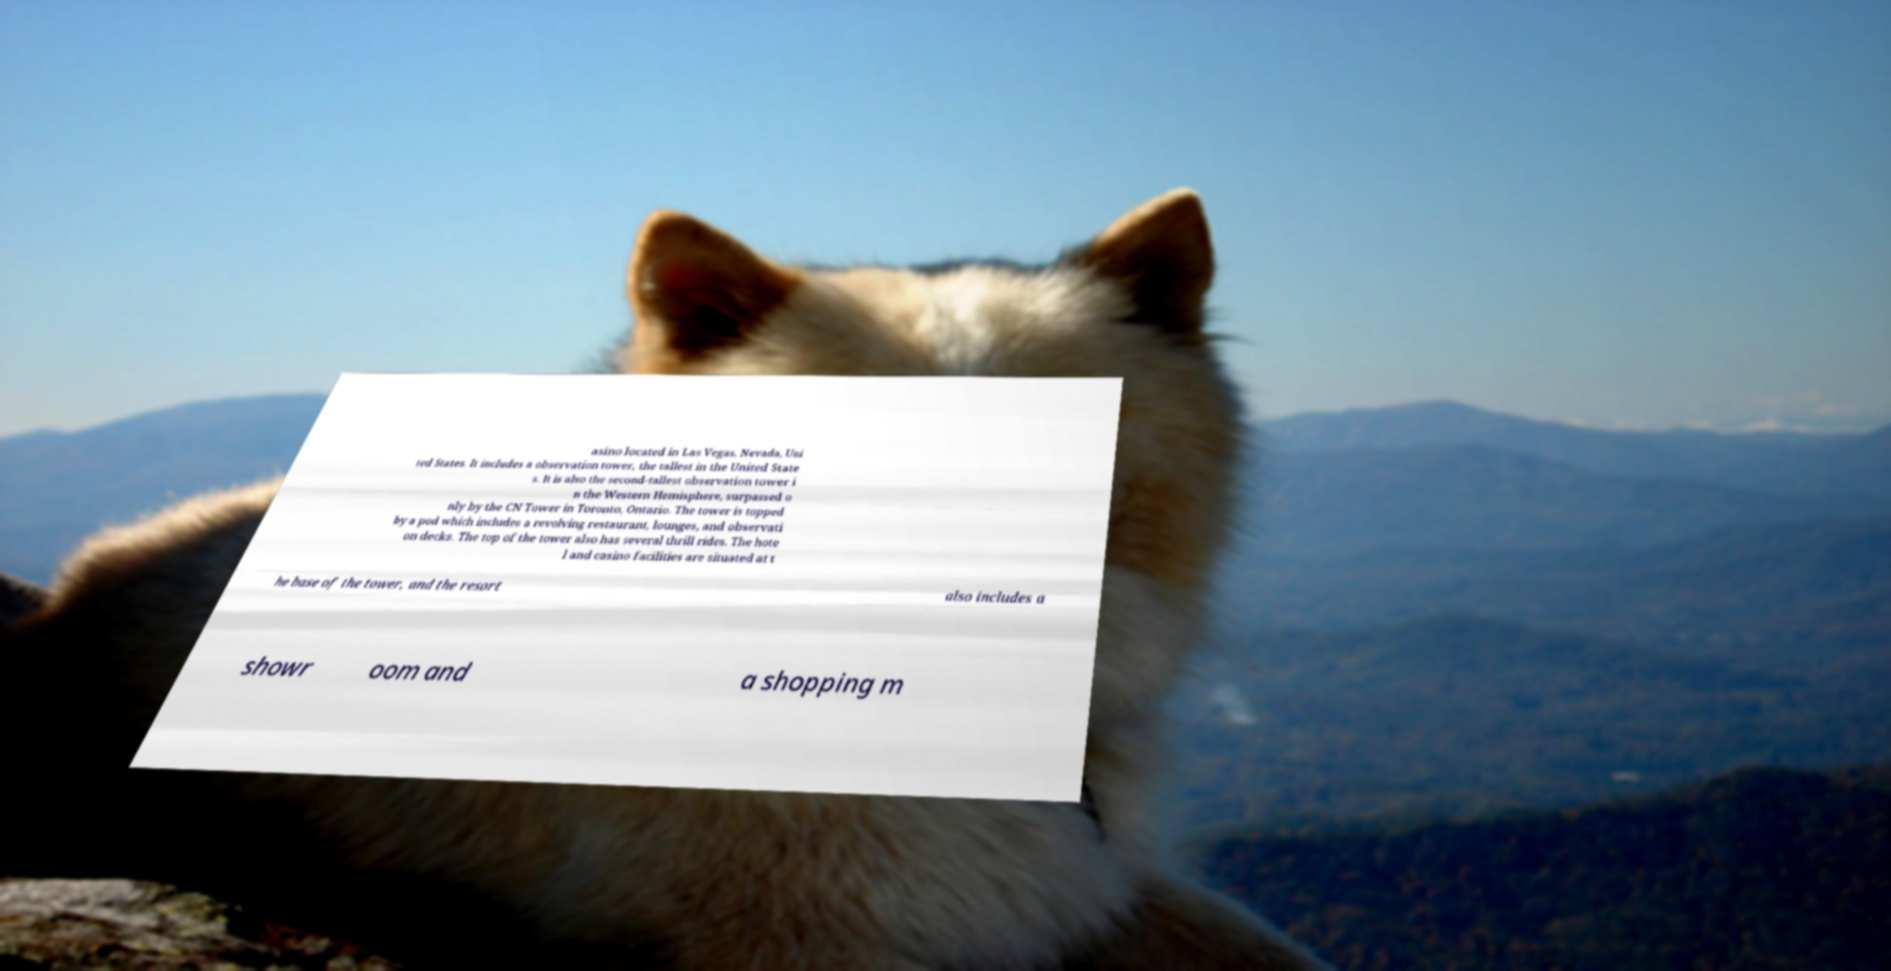What messages or text are displayed in this image? I need them in a readable, typed format. asino located in Las Vegas, Nevada, Uni ted States. It includes a observation tower, the tallest in the United State s. It is also the second-tallest observation tower i n the Western Hemisphere, surpassed o nly by the CN Tower in Toronto, Ontario. The tower is topped by a pod which includes a revolving restaurant, lounges, and observati on decks. The top of the tower also has several thrill rides. The hote l and casino facilities are situated at t he base of the tower, and the resort also includes a showr oom and a shopping m 